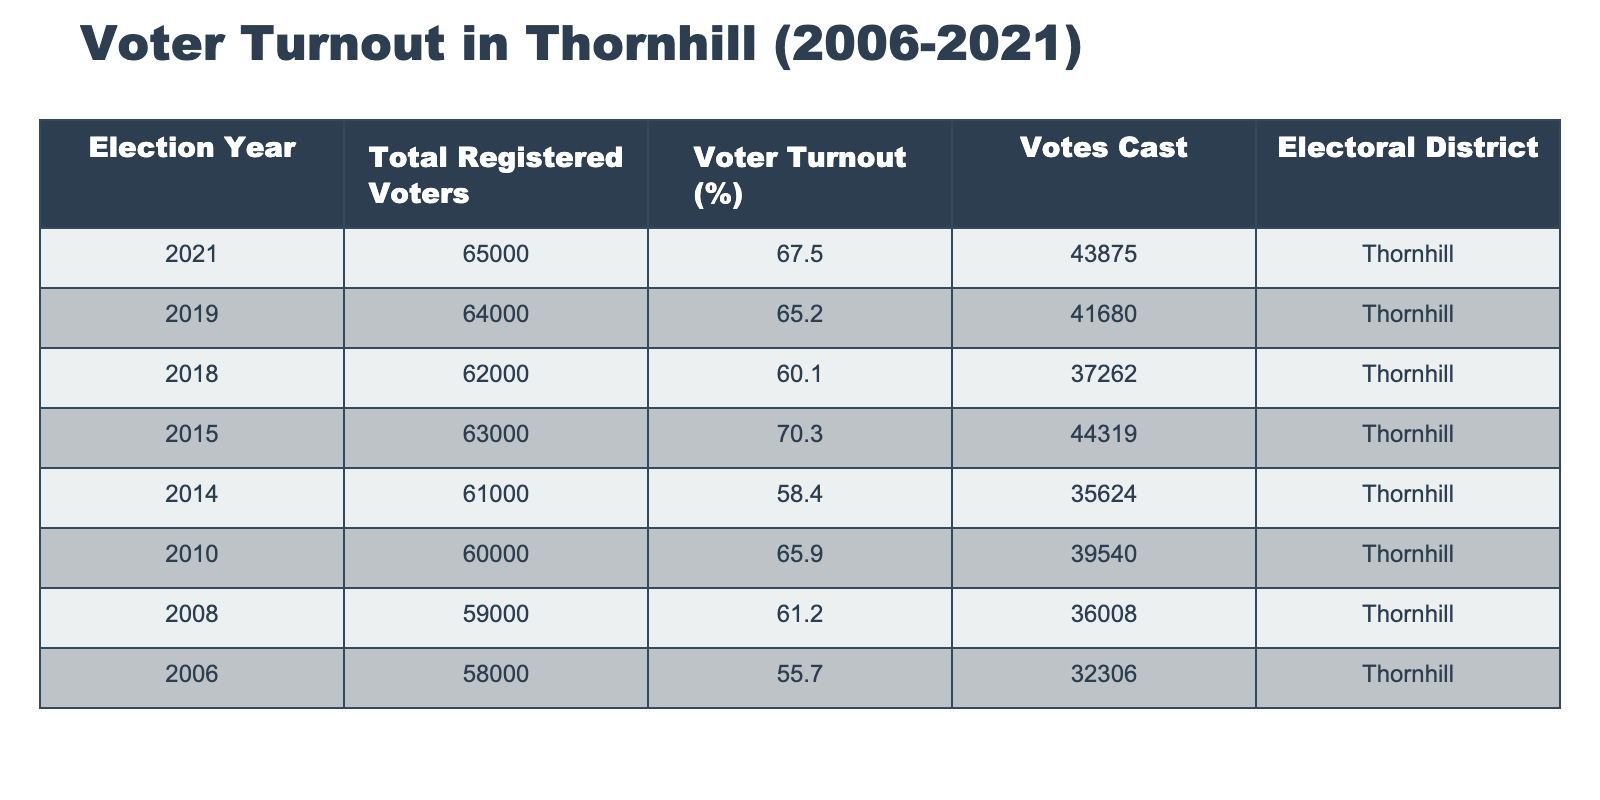What was the voter turnout percentage in Thornhill for the 2021 election? According to the table, the voter turnout percentage for the Thornhill electoral district in the 2021 election is 67.5%.
Answer: 67.5% How many votes were cast in the 2019 election in Thornhill? The table indicates that the number of votes cast in the 2019 election for Thornhill was 41,680.
Answer: 41,680 What is the difference in voter turnout between the 2015 and 2018 elections? To find the difference, subtract the voter turnout percentage of 2018 (60.1%) from that of 2015 (70.3%). Thus, 70.3% - 60.1% = 10.2%. So, the difference in voter turnout is 10.2%.
Answer: 10.2% In which election year did Thornhill have the lowest voter turnout? By scanning the table, the lowest voter turnout in Thornhill was in the year 2014, where the percentage was 58.4%.
Answer: 2014 What is the average voter turnout percentage from 2006 to 2021 for Thornhill? To calculate the average: add up all the voter turnout percentages: 67.5 + 65.2 + 60.1 + 70.3 + 58.4 + 65.9 + 61.2 + 55.7 =  530.3. There are 8 elections, so divide the total by 8, which gives 530.3 / 8 = 66.2875. Rounding off, the average voter turnout percentage is 66.29%.
Answer: 66.29% Was voter turnout higher in 2010 compared to 2018? In 2010, the voter turnout was 65.9%, while in 2018 it was 60.1%. Since 65.9% is greater than 60.1%, the voter turnout was indeed higher in 2010.
Answer: Yes How many registered voters participated in the 2014 election compared to the 2019 election? For the 2014 election, the total registered voters were 61,000, and in 2019, they were 64,000. The difference in registered voters is 64,000 - 61,000 = 3,000, indicating that there were 3,000 more registered voters in 2019 compared to 2014.
Answer: 3,000 more What was the total number of votes cast in the elections from 2010 to 2021 combined? To calculate the total votes from 2010 to 2021, add up the votes cast for 2010 (39,540), 2014 (35,624), 2015 (44,319), 2018 (37,262), and 2021 (43,875). The total is 39,540 + 35,624 + 44,319 + 37,262 + 43,875 = 200,620.
Answer: 200,620 